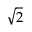Convert formula to latex. <formula><loc_0><loc_0><loc_500><loc_500>\sqrt { 2 }</formula> 